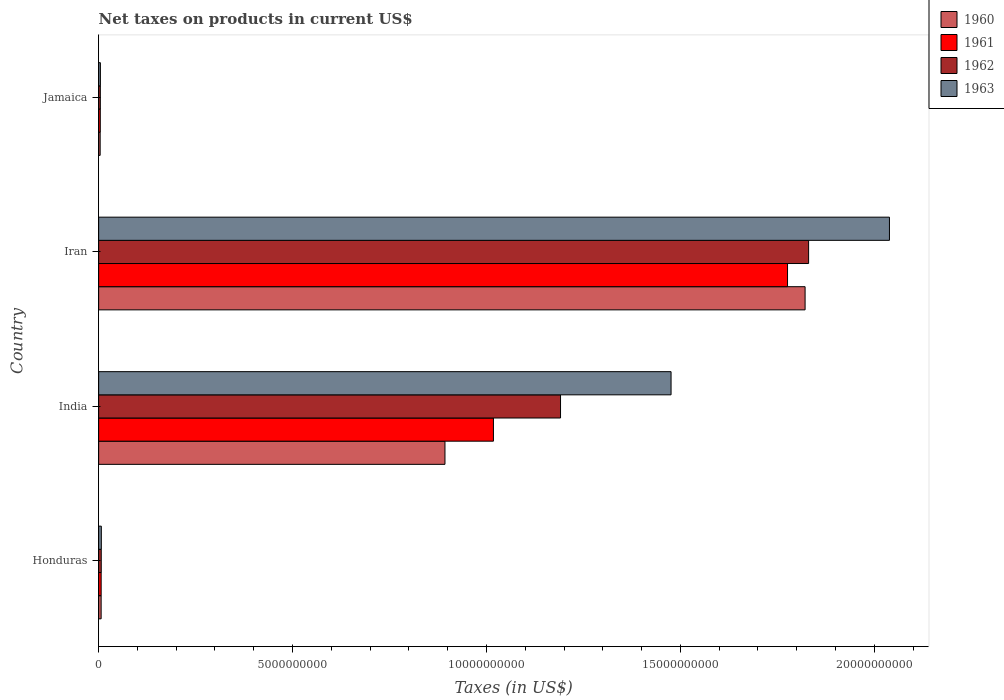How many groups of bars are there?
Your answer should be compact. 4. Are the number of bars per tick equal to the number of legend labels?
Provide a succinct answer. Yes. What is the label of the 1st group of bars from the top?
Ensure brevity in your answer.  Jamaica. What is the net taxes on products in 1963 in India?
Ensure brevity in your answer.  1.48e+1. Across all countries, what is the maximum net taxes on products in 1962?
Offer a terse response. 1.83e+1. Across all countries, what is the minimum net taxes on products in 1961?
Ensure brevity in your answer.  4.26e+07. In which country was the net taxes on products in 1960 maximum?
Your answer should be very brief. Iran. In which country was the net taxes on products in 1961 minimum?
Provide a succinct answer. Jamaica. What is the total net taxes on products in 1960 in the graph?
Offer a very short reply. 2.72e+1. What is the difference between the net taxes on products in 1960 in Honduras and that in Iran?
Your answer should be compact. -1.82e+1. What is the difference between the net taxes on products in 1963 in Jamaica and the net taxes on products in 1960 in India?
Make the answer very short. -8.88e+09. What is the average net taxes on products in 1963 per country?
Provide a short and direct response. 8.82e+09. What is the difference between the net taxes on products in 1961 and net taxes on products in 1960 in India?
Your answer should be compact. 1.25e+09. In how many countries, is the net taxes on products in 1961 greater than 18000000000 US$?
Your answer should be very brief. 0. What is the ratio of the net taxes on products in 1962 in Honduras to that in India?
Your answer should be compact. 0.01. What is the difference between the highest and the second highest net taxes on products in 1962?
Keep it short and to the point. 6.40e+09. What is the difference between the highest and the lowest net taxes on products in 1960?
Give a very brief answer. 1.82e+1. What does the 1st bar from the top in Honduras represents?
Your answer should be compact. 1963. Is it the case that in every country, the sum of the net taxes on products in 1963 and net taxes on products in 1961 is greater than the net taxes on products in 1962?
Offer a very short reply. Yes. Are all the bars in the graph horizontal?
Keep it short and to the point. Yes. What is the difference between two consecutive major ticks on the X-axis?
Your answer should be very brief. 5.00e+09. How many legend labels are there?
Offer a terse response. 4. How are the legend labels stacked?
Your answer should be compact. Vertical. What is the title of the graph?
Offer a terse response. Net taxes on products in current US$. What is the label or title of the X-axis?
Give a very brief answer. Taxes (in US$). What is the label or title of the Y-axis?
Provide a succinct answer. Country. What is the Taxes (in US$) in 1960 in Honduras?
Provide a short and direct response. 6.45e+07. What is the Taxes (in US$) of 1961 in Honduras?
Ensure brevity in your answer.  6.50e+07. What is the Taxes (in US$) of 1962 in Honduras?
Your answer should be compact. 6.73e+07. What is the Taxes (in US$) of 1963 in Honduras?
Offer a terse response. 6.96e+07. What is the Taxes (in US$) of 1960 in India?
Give a very brief answer. 8.93e+09. What is the Taxes (in US$) of 1961 in India?
Your response must be concise. 1.02e+1. What is the Taxes (in US$) in 1962 in India?
Offer a very short reply. 1.19e+1. What is the Taxes (in US$) of 1963 in India?
Provide a succinct answer. 1.48e+1. What is the Taxes (in US$) in 1960 in Iran?
Ensure brevity in your answer.  1.82e+1. What is the Taxes (in US$) of 1961 in Iran?
Your response must be concise. 1.78e+1. What is the Taxes (in US$) of 1962 in Iran?
Offer a very short reply. 1.83e+1. What is the Taxes (in US$) of 1963 in Iran?
Give a very brief answer. 2.04e+1. What is the Taxes (in US$) of 1960 in Jamaica?
Make the answer very short. 3.93e+07. What is the Taxes (in US$) of 1961 in Jamaica?
Your response must be concise. 4.26e+07. What is the Taxes (in US$) in 1962 in Jamaica?
Ensure brevity in your answer.  4.35e+07. What is the Taxes (in US$) in 1963 in Jamaica?
Provide a short and direct response. 4.54e+07. Across all countries, what is the maximum Taxes (in US$) of 1960?
Give a very brief answer. 1.82e+1. Across all countries, what is the maximum Taxes (in US$) of 1961?
Ensure brevity in your answer.  1.78e+1. Across all countries, what is the maximum Taxes (in US$) of 1962?
Your answer should be compact. 1.83e+1. Across all countries, what is the maximum Taxes (in US$) in 1963?
Keep it short and to the point. 2.04e+1. Across all countries, what is the minimum Taxes (in US$) of 1960?
Your answer should be very brief. 3.93e+07. Across all countries, what is the minimum Taxes (in US$) of 1961?
Give a very brief answer. 4.26e+07. Across all countries, what is the minimum Taxes (in US$) of 1962?
Your answer should be very brief. 4.35e+07. Across all countries, what is the minimum Taxes (in US$) in 1963?
Make the answer very short. 4.54e+07. What is the total Taxes (in US$) in 1960 in the graph?
Your response must be concise. 2.72e+1. What is the total Taxes (in US$) in 1961 in the graph?
Keep it short and to the point. 2.81e+1. What is the total Taxes (in US$) of 1962 in the graph?
Keep it short and to the point. 3.03e+1. What is the total Taxes (in US$) in 1963 in the graph?
Ensure brevity in your answer.  3.53e+1. What is the difference between the Taxes (in US$) of 1960 in Honduras and that in India?
Give a very brief answer. -8.87e+09. What is the difference between the Taxes (in US$) of 1961 in Honduras and that in India?
Ensure brevity in your answer.  -1.01e+1. What is the difference between the Taxes (in US$) of 1962 in Honduras and that in India?
Give a very brief answer. -1.18e+1. What is the difference between the Taxes (in US$) of 1963 in Honduras and that in India?
Offer a very short reply. -1.47e+1. What is the difference between the Taxes (in US$) of 1960 in Honduras and that in Iran?
Provide a short and direct response. -1.82e+1. What is the difference between the Taxes (in US$) of 1961 in Honduras and that in Iran?
Provide a succinct answer. -1.77e+1. What is the difference between the Taxes (in US$) of 1962 in Honduras and that in Iran?
Give a very brief answer. -1.82e+1. What is the difference between the Taxes (in US$) of 1963 in Honduras and that in Iran?
Make the answer very short. -2.03e+1. What is the difference between the Taxes (in US$) of 1960 in Honduras and that in Jamaica?
Your response must be concise. 2.52e+07. What is the difference between the Taxes (in US$) in 1961 in Honduras and that in Jamaica?
Provide a succinct answer. 2.24e+07. What is the difference between the Taxes (in US$) of 1962 in Honduras and that in Jamaica?
Keep it short and to the point. 2.38e+07. What is the difference between the Taxes (in US$) of 1963 in Honduras and that in Jamaica?
Provide a succinct answer. 2.42e+07. What is the difference between the Taxes (in US$) in 1960 in India and that in Iran?
Make the answer very short. -9.29e+09. What is the difference between the Taxes (in US$) in 1961 in India and that in Iran?
Keep it short and to the point. -7.58e+09. What is the difference between the Taxes (in US$) of 1962 in India and that in Iran?
Provide a short and direct response. -6.40e+09. What is the difference between the Taxes (in US$) of 1963 in India and that in Iran?
Provide a succinct answer. -5.63e+09. What is the difference between the Taxes (in US$) in 1960 in India and that in Jamaica?
Offer a terse response. 8.89e+09. What is the difference between the Taxes (in US$) in 1961 in India and that in Jamaica?
Offer a terse response. 1.01e+1. What is the difference between the Taxes (in US$) of 1962 in India and that in Jamaica?
Your response must be concise. 1.19e+1. What is the difference between the Taxes (in US$) of 1963 in India and that in Jamaica?
Offer a terse response. 1.47e+1. What is the difference between the Taxes (in US$) of 1960 in Iran and that in Jamaica?
Offer a very short reply. 1.82e+1. What is the difference between the Taxes (in US$) of 1961 in Iran and that in Jamaica?
Your answer should be compact. 1.77e+1. What is the difference between the Taxes (in US$) of 1962 in Iran and that in Jamaica?
Keep it short and to the point. 1.83e+1. What is the difference between the Taxes (in US$) in 1963 in Iran and that in Jamaica?
Your answer should be compact. 2.03e+1. What is the difference between the Taxes (in US$) in 1960 in Honduras and the Taxes (in US$) in 1961 in India?
Give a very brief answer. -1.01e+1. What is the difference between the Taxes (in US$) in 1960 in Honduras and the Taxes (in US$) in 1962 in India?
Your answer should be compact. -1.18e+1. What is the difference between the Taxes (in US$) in 1960 in Honduras and the Taxes (in US$) in 1963 in India?
Your answer should be very brief. -1.47e+1. What is the difference between the Taxes (in US$) of 1961 in Honduras and the Taxes (in US$) of 1962 in India?
Your response must be concise. -1.18e+1. What is the difference between the Taxes (in US$) of 1961 in Honduras and the Taxes (in US$) of 1963 in India?
Make the answer very short. -1.47e+1. What is the difference between the Taxes (in US$) in 1962 in Honduras and the Taxes (in US$) in 1963 in India?
Provide a succinct answer. -1.47e+1. What is the difference between the Taxes (in US$) of 1960 in Honduras and the Taxes (in US$) of 1961 in Iran?
Make the answer very short. -1.77e+1. What is the difference between the Taxes (in US$) in 1960 in Honduras and the Taxes (in US$) in 1962 in Iran?
Provide a short and direct response. -1.82e+1. What is the difference between the Taxes (in US$) in 1960 in Honduras and the Taxes (in US$) in 1963 in Iran?
Give a very brief answer. -2.03e+1. What is the difference between the Taxes (in US$) of 1961 in Honduras and the Taxes (in US$) of 1962 in Iran?
Keep it short and to the point. -1.82e+1. What is the difference between the Taxes (in US$) of 1961 in Honduras and the Taxes (in US$) of 1963 in Iran?
Ensure brevity in your answer.  -2.03e+1. What is the difference between the Taxes (in US$) of 1962 in Honduras and the Taxes (in US$) of 1963 in Iran?
Your answer should be compact. -2.03e+1. What is the difference between the Taxes (in US$) of 1960 in Honduras and the Taxes (in US$) of 1961 in Jamaica?
Give a very brief answer. 2.19e+07. What is the difference between the Taxes (in US$) in 1960 in Honduras and the Taxes (in US$) in 1962 in Jamaica?
Make the answer very short. 2.10e+07. What is the difference between the Taxes (in US$) of 1960 in Honduras and the Taxes (in US$) of 1963 in Jamaica?
Your answer should be compact. 1.91e+07. What is the difference between the Taxes (in US$) of 1961 in Honduras and the Taxes (in US$) of 1962 in Jamaica?
Provide a short and direct response. 2.15e+07. What is the difference between the Taxes (in US$) in 1961 in Honduras and the Taxes (in US$) in 1963 in Jamaica?
Keep it short and to the point. 1.96e+07. What is the difference between the Taxes (in US$) in 1962 in Honduras and the Taxes (in US$) in 1963 in Jamaica?
Your answer should be compact. 2.19e+07. What is the difference between the Taxes (in US$) in 1960 in India and the Taxes (in US$) in 1961 in Iran?
Your answer should be compact. -8.83e+09. What is the difference between the Taxes (in US$) in 1960 in India and the Taxes (in US$) in 1962 in Iran?
Provide a succinct answer. -9.38e+09. What is the difference between the Taxes (in US$) of 1960 in India and the Taxes (in US$) of 1963 in Iran?
Your answer should be compact. -1.15e+1. What is the difference between the Taxes (in US$) in 1961 in India and the Taxes (in US$) in 1962 in Iran?
Your answer should be compact. -8.13e+09. What is the difference between the Taxes (in US$) in 1961 in India and the Taxes (in US$) in 1963 in Iran?
Offer a very short reply. -1.02e+1. What is the difference between the Taxes (in US$) of 1962 in India and the Taxes (in US$) of 1963 in Iran?
Give a very brief answer. -8.48e+09. What is the difference between the Taxes (in US$) in 1960 in India and the Taxes (in US$) in 1961 in Jamaica?
Your response must be concise. 8.89e+09. What is the difference between the Taxes (in US$) in 1960 in India and the Taxes (in US$) in 1962 in Jamaica?
Your answer should be very brief. 8.89e+09. What is the difference between the Taxes (in US$) of 1960 in India and the Taxes (in US$) of 1963 in Jamaica?
Keep it short and to the point. 8.88e+09. What is the difference between the Taxes (in US$) in 1961 in India and the Taxes (in US$) in 1962 in Jamaica?
Your answer should be compact. 1.01e+1. What is the difference between the Taxes (in US$) of 1961 in India and the Taxes (in US$) of 1963 in Jamaica?
Your answer should be very brief. 1.01e+1. What is the difference between the Taxes (in US$) in 1962 in India and the Taxes (in US$) in 1963 in Jamaica?
Your answer should be very brief. 1.19e+1. What is the difference between the Taxes (in US$) of 1960 in Iran and the Taxes (in US$) of 1961 in Jamaica?
Ensure brevity in your answer.  1.82e+1. What is the difference between the Taxes (in US$) in 1960 in Iran and the Taxes (in US$) in 1962 in Jamaica?
Provide a short and direct response. 1.82e+1. What is the difference between the Taxes (in US$) in 1960 in Iran and the Taxes (in US$) in 1963 in Jamaica?
Your answer should be compact. 1.82e+1. What is the difference between the Taxes (in US$) of 1961 in Iran and the Taxes (in US$) of 1962 in Jamaica?
Your response must be concise. 1.77e+1. What is the difference between the Taxes (in US$) in 1961 in Iran and the Taxes (in US$) in 1963 in Jamaica?
Provide a short and direct response. 1.77e+1. What is the difference between the Taxes (in US$) in 1962 in Iran and the Taxes (in US$) in 1963 in Jamaica?
Your answer should be very brief. 1.83e+1. What is the average Taxes (in US$) in 1960 per country?
Provide a succinct answer. 6.81e+09. What is the average Taxes (in US$) of 1961 per country?
Make the answer very short. 7.01e+09. What is the average Taxes (in US$) of 1962 per country?
Your answer should be very brief. 7.58e+09. What is the average Taxes (in US$) of 1963 per country?
Provide a short and direct response. 8.82e+09. What is the difference between the Taxes (in US$) in 1960 and Taxes (in US$) in 1961 in Honduras?
Your answer should be compact. -5.00e+05. What is the difference between the Taxes (in US$) of 1960 and Taxes (in US$) of 1962 in Honduras?
Make the answer very short. -2.80e+06. What is the difference between the Taxes (in US$) in 1960 and Taxes (in US$) in 1963 in Honduras?
Make the answer very short. -5.10e+06. What is the difference between the Taxes (in US$) of 1961 and Taxes (in US$) of 1962 in Honduras?
Keep it short and to the point. -2.30e+06. What is the difference between the Taxes (in US$) of 1961 and Taxes (in US$) of 1963 in Honduras?
Ensure brevity in your answer.  -4.60e+06. What is the difference between the Taxes (in US$) of 1962 and Taxes (in US$) of 1963 in Honduras?
Your answer should be very brief. -2.30e+06. What is the difference between the Taxes (in US$) in 1960 and Taxes (in US$) in 1961 in India?
Offer a terse response. -1.25e+09. What is the difference between the Taxes (in US$) of 1960 and Taxes (in US$) of 1962 in India?
Your answer should be compact. -2.98e+09. What is the difference between the Taxes (in US$) of 1960 and Taxes (in US$) of 1963 in India?
Give a very brief answer. -5.83e+09. What is the difference between the Taxes (in US$) in 1961 and Taxes (in US$) in 1962 in India?
Ensure brevity in your answer.  -1.73e+09. What is the difference between the Taxes (in US$) in 1961 and Taxes (in US$) in 1963 in India?
Provide a succinct answer. -4.58e+09. What is the difference between the Taxes (in US$) of 1962 and Taxes (in US$) of 1963 in India?
Ensure brevity in your answer.  -2.85e+09. What is the difference between the Taxes (in US$) in 1960 and Taxes (in US$) in 1961 in Iran?
Your answer should be very brief. 4.53e+08. What is the difference between the Taxes (in US$) in 1960 and Taxes (in US$) in 1962 in Iran?
Your answer should be compact. -9.06e+07. What is the difference between the Taxes (in US$) of 1960 and Taxes (in US$) of 1963 in Iran?
Offer a very short reply. -2.18e+09. What is the difference between the Taxes (in US$) of 1961 and Taxes (in US$) of 1962 in Iran?
Provide a succinct answer. -5.44e+08. What is the difference between the Taxes (in US$) of 1961 and Taxes (in US$) of 1963 in Iran?
Your response must be concise. -2.63e+09. What is the difference between the Taxes (in US$) of 1962 and Taxes (in US$) of 1963 in Iran?
Keep it short and to the point. -2.08e+09. What is the difference between the Taxes (in US$) in 1960 and Taxes (in US$) in 1961 in Jamaica?
Offer a very short reply. -3.30e+06. What is the difference between the Taxes (in US$) in 1960 and Taxes (in US$) in 1962 in Jamaica?
Your response must be concise. -4.20e+06. What is the difference between the Taxes (in US$) of 1960 and Taxes (in US$) of 1963 in Jamaica?
Your response must be concise. -6.10e+06. What is the difference between the Taxes (in US$) of 1961 and Taxes (in US$) of 1962 in Jamaica?
Your answer should be very brief. -9.00e+05. What is the difference between the Taxes (in US$) in 1961 and Taxes (in US$) in 1963 in Jamaica?
Your response must be concise. -2.80e+06. What is the difference between the Taxes (in US$) in 1962 and Taxes (in US$) in 1963 in Jamaica?
Your answer should be very brief. -1.90e+06. What is the ratio of the Taxes (in US$) of 1960 in Honduras to that in India?
Provide a succinct answer. 0.01. What is the ratio of the Taxes (in US$) in 1961 in Honduras to that in India?
Your response must be concise. 0.01. What is the ratio of the Taxes (in US$) of 1962 in Honduras to that in India?
Your answer should be compact. 0.01. What is the ratio of the Taxes (in US$) of 1963 in Honduras to that in India?
Give a very brief answer. 0. What is the ratio of the Taxes (in US$) in 1960 in Honduras to that in Iran?
Offer a very short reply. 0. What is the ratio of the Taxes (in US$) of 1961 in Honduras to that in Iran?
Your response must be concise. 0. What is the ratio of the Taxes (in US$) of 1962 in Honduras to that in Iran?
Offer a very short reply. 0. What is the ratio of the Taxes (in US$) of 1963 in Honduras to that in Iran?
Offer a very short reply. 0. What is the ratio of the Taxes (in US$) in 1960 in Honduras to that in Jamaica?
Your response must be concise. 1.64. What is the ratio of the Taxes (in US$) of 1961 in Honduras to that in Jamaica?
Provide a succinct answer. 1.53. What is the ratio of the Taxes (in US$) of 1962 in Honduras to that in Jamaica?
Your answer should be compact. 1.55. What is the ratio of the Taxes (in US$) of 1963 in Honduras to that in Jamaica?
Make the answer very short. 1.53. What is the ratio of the Taxes (in US$) of 1960 in India to that in Iran?
Give a very brief answer. 0.49. What is the ratio of the Taxes (in US$) of 1961 in India to that in Iran?
Provide a succinct answer. 0.57. What is the ratio of the Taxes (in US$) of 1962 in India to that in Iran?
Give a very brief answer. 0.65. What is the ratio of the Taxes (in US$) in 1963 in India to that in Iran?
Give a very brief answer. 0.72. What is the ratio of the Taxes (in US$) of 1960 in India to that in Jamaica?
Keep it short and to the point. 227.23. What is the ratio of the Taxes (in US$) of 1961 in India to that in Jamaica?
Offer a terse response. 238.97. What is the ratio of the Taxes (in US$) in 1962 in India to that in Jamaica?
Your response must be concise. 273.79. What is the ratio of the Taxes (in US$) in 1963 in India to that in Jamaica?
Offer a very short reply. 325.11. What is the ratio of the Taxes (in US$) in 1960 in Iran to that in Jamaica?
Your answer should be very brief. 463.51. What is the ratio of the Taxes (in US$) of 1961 in Iran to that in Jamaica?
Give a very brief answer. 416.97. What is the ratio of the Taxes (in US$) in 1962 in Iran to that in Jamaica?
Your answer should be compact. 420.84. What is the ratio of the Taxes (in US$) in 1963 in Iran to that in Jamaica?
Your answer should be compact. 449.14. What is the difference between the highest and the second highest Taxes (in US$) in 1960?
Your response must be concise. 9.29e+09. What is the difference between the highest and the second highest Taxes (in US$) of 1961?
Your answer should be compact. 7.58e+09. What is the difference between the highest and the second highest Taxes (in US$) of 1962?
Your response must be concise. 6.40e+09. What is the difference between the highest and the second highest Taxes (in US$) of 1963?
Make the answer very short. 5.63e+09. What is the difference between the highest and the lowest Taxes (in US$) of 1960?
Give a very brief answer. 1.82e+1. What is the difference between the highest and the lowest Taxes (in US$) in 1961?
Provide a short and direct response. 1.77e+1. What is the difference between the highest and the lowest Taxes (in US$) of 1962?
Offer a terse response. 1.83e+1. What is the difference between the highest and the lowest Taxes (in US$) in 1963?
Ensure brevity in your answer.  2.03e+1. 